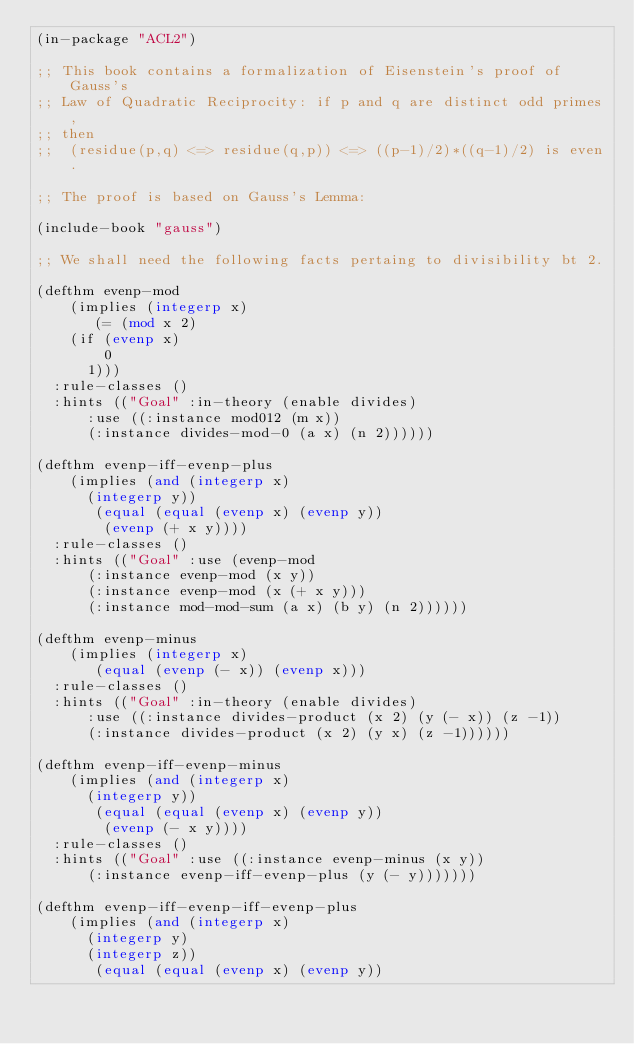Convert code to text. <code><loc_0><loc_0><loc_500><loc_500><_Lisp_>(in-package "ACL2")

;; This book contains a formalization of Eisenstein's proof of Gauss's 
;; Law of Quadratic Reciprocity: if p and q are distinct odd primes, 
;; then
;;  (residue(p,q) <=> residue(q,p)) <=> ((p-1)/2)*((q-1)/2) is even.

;; The proof is based on Gauss's Lemma:

(include-book "gauss")

;; We shall need the following facts pertaing to divisibility bt 2.

(defthm evenp-mod
    (implies (integerp x)
	     (= (mod x 2)
		(if (evenp x)
		    0
		  1)))
  :rule-classes ()
  :hints (("Goal" :in-theory (enable divides)
		  :use ((:instance mod012 (m x))
			(:instance divides-mod-0 (a x) (n 2))))))

(defthm evenp-iff-evenp-plus
    (implies (and (integerp x)
		  (integerp y))
	     (equal (equal (evenp x) (evenp y))
		    (evenp (+ x y))))
  :rule-classes ()
  :hints (("Goal" :use (evenp-mod
			(:instance evenp-mod (x y))
			(:instance evenp-mod (x (+ x y)))
			(:instance mod-mod-sum (a x) (b y) (n 2))))))

(defthm evenp-minus
    (implies (integerp x)
	     (equal (evenp (- x)) (evenp x)))
  :rule-classes ()
  :hints (("Goal" :in-theory (enable divides)
		  :use ((:instance divides-product (x 2) (y (- x)) (z -1))
			(:instance divides-product (x 2) (y x) (z -1))))))

(defthm evenp-iff-evenp-minus
    (implies (and (integerp x)
		  (integerp y))
	     (equal (equal (evenp x) (evenp y))
		    (evenp (- x y))))
  :rule-classes ()
  :hints (("Goal" :use ((:instance evenp-minus (x y))
			(:instance evenp-iff-evenp-plus (y (- y)))))))

(defthm evenp-iff-evenp-iff-evenp-plus
    (implies (and (integerp x)
		  (integerp y)
		  (integerp z))
	     (equal (equal (evenp x) (evenp y))</code> 